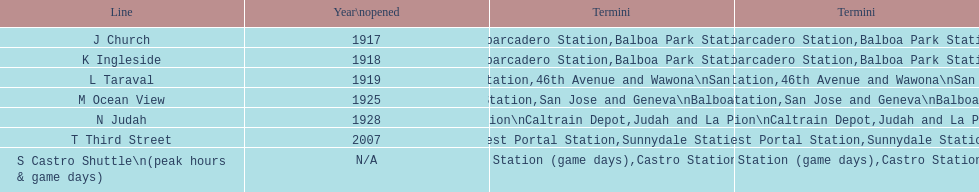On days when games are played, which line would you prefer to use? S Castro Shuttle. 